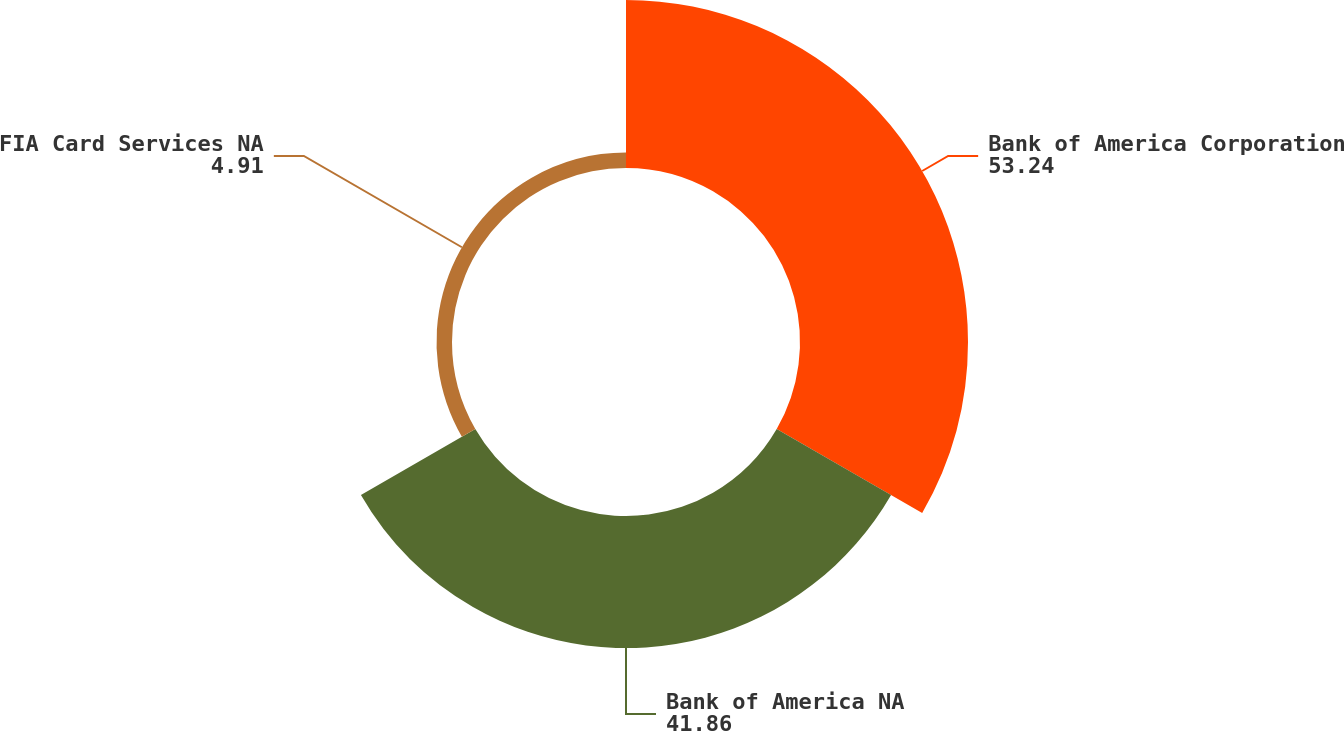<chart> <loc_0><loc_0><loc_500><loc_500><pie_chart><fcel>Bank of America Corporation<fcel>Bank of America NA<fcel>FIA Card Services NA<nl><fcel>53.24%<fcel>41.86%<fcel>4.91%<nl></chart> 